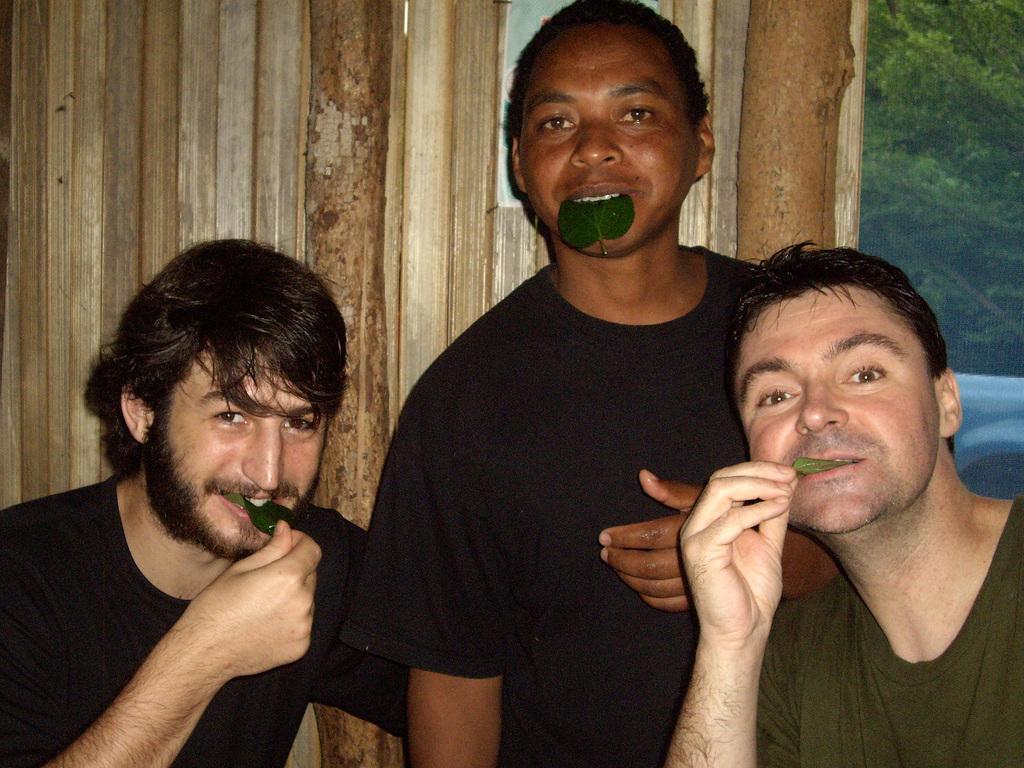How would you summarize this image in a sentence or two? In this image there are three men, they are holding a leaf, there is a wooden wall behind the persons, there is an object on the wooden wall, there are trees towards the right of the image. 